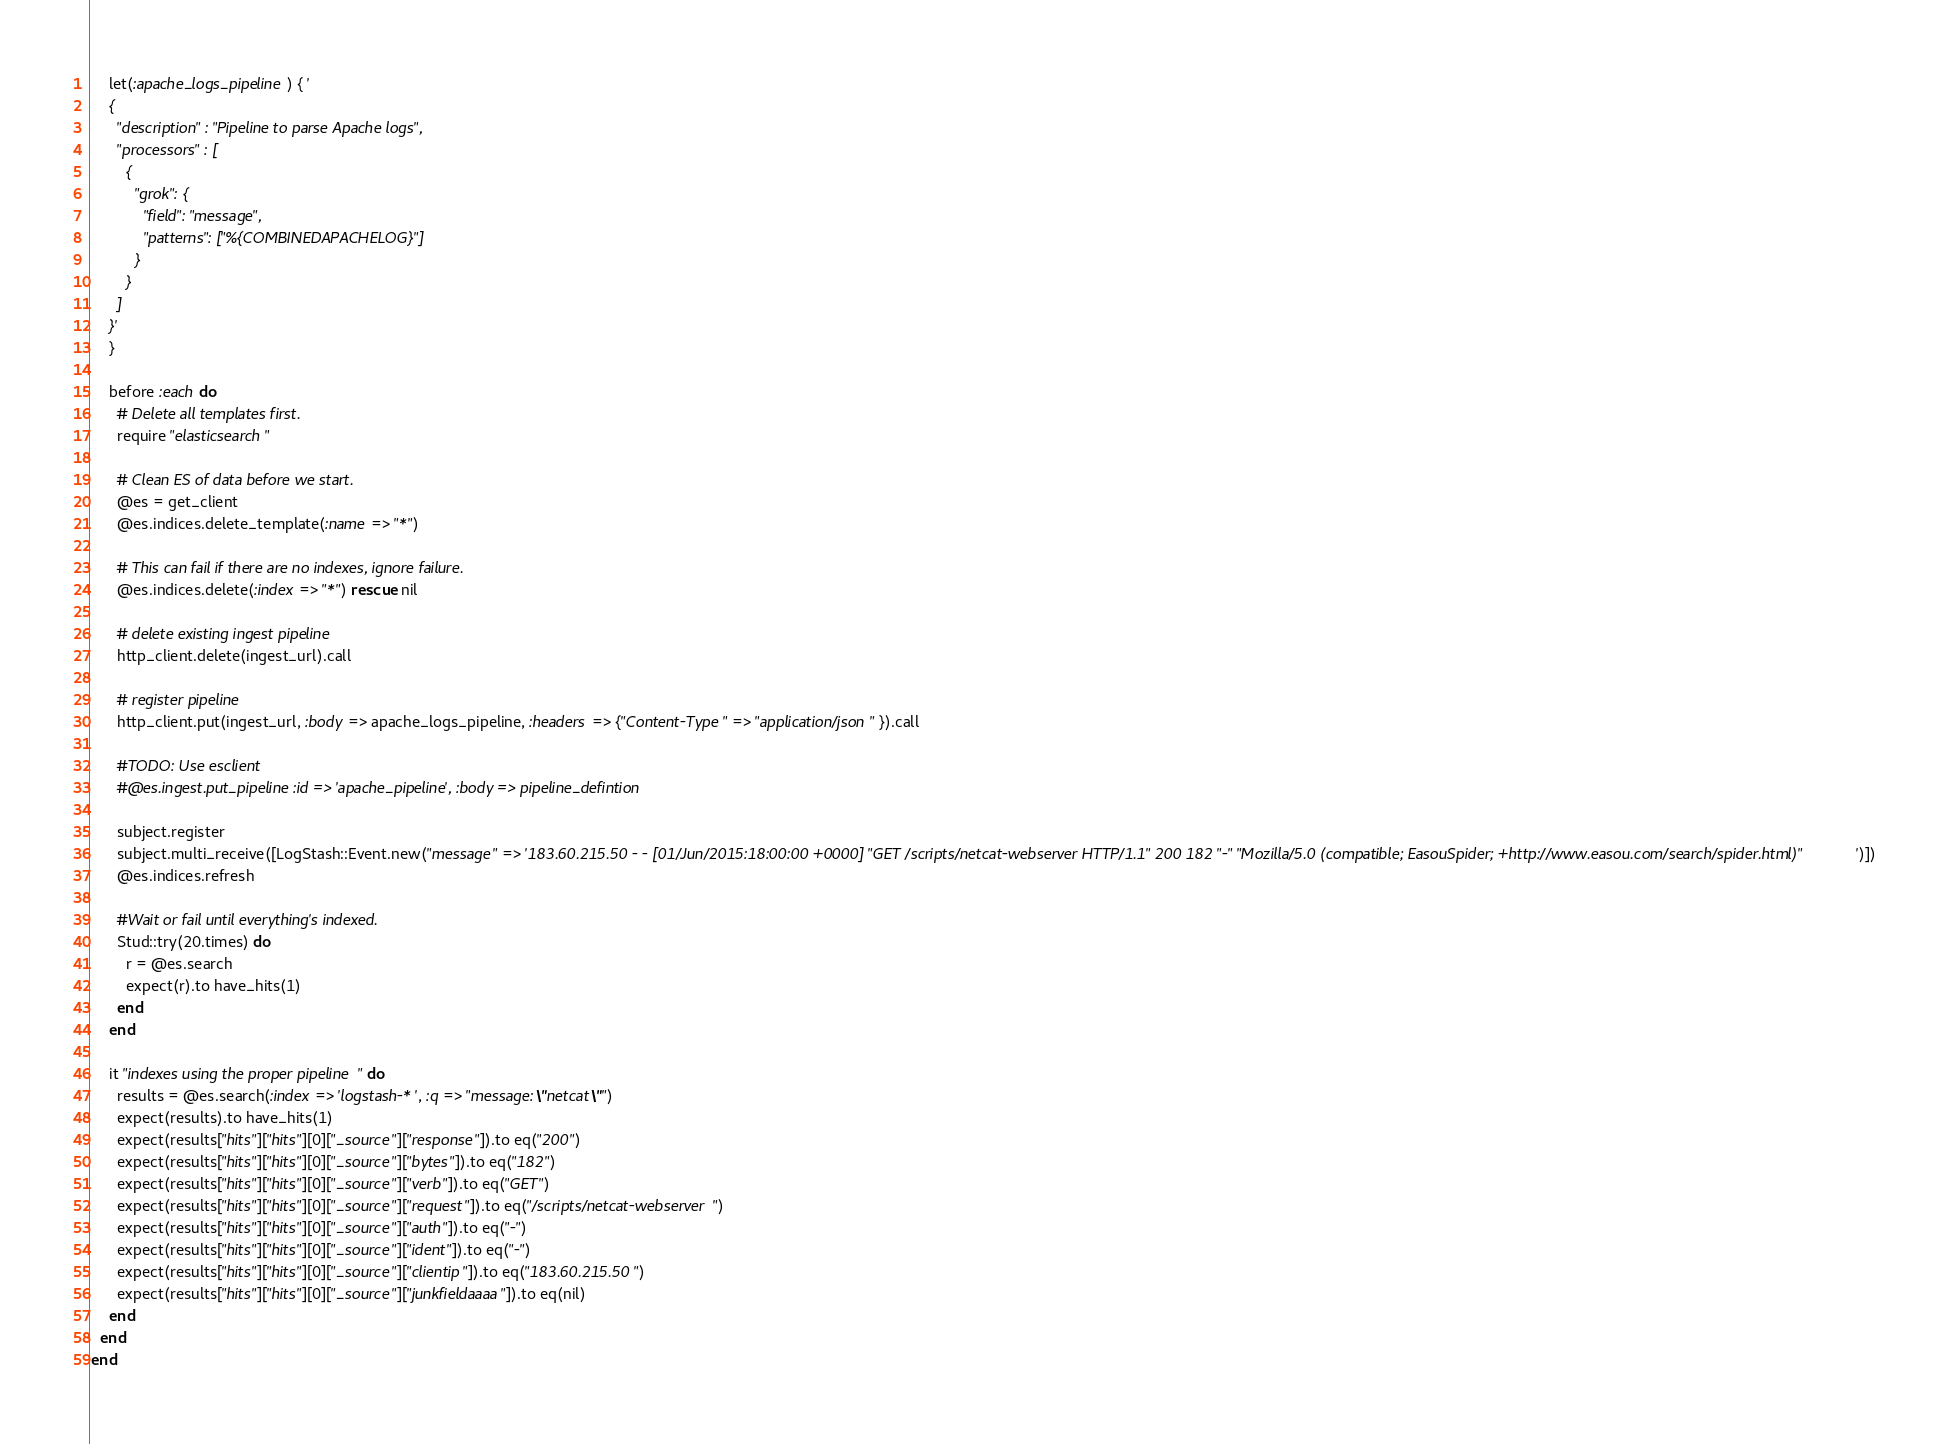<code> <loc_0><loc_0><loc_500><loc_500><_Ruby_>    let(:apache_logs_pipeline) { '
    {
      "description" : "Pipeline to parse Apache logs",
      "processors" : [
        {
          "grok": {
            "field": "message",
            "patterns": ["%{COMBINEDAPACHELOG}"]
          }
        }
      ]
    }'
    }

    before :each do
      # Delete all templates first.
      require "elasticsearch"

      # Clean ES of data before we start.
      @es = get_client
      @es.indices.delete_template(:name => "*")

      # This can fail if there are no indexes, ignore failure.
      @es.indices.delete(:index => "*") rescue nil

      # delete existing ingest pipeline
      http_client.delete(ingest_url).call

      # register pipeline
      http_client.put(ingest_url, :body => apache_logs_pipeline, :headers => {"Content-Type" => "application/json" }).call

      #TODO: Use esclient
      #@es.ingest.put_pipeline :id => 'apache_pipeline', :body => pipeline_defintion

      subject.register
      subject.multi_receive([LogStash::Event.new("message" => '183.60.215.50 - - [01/Jun/2015:18:00:00 +0000] "GET /scripts/netcat-webserver HTTP/1.1" 200 182 "-" "Mozilla/5.0 (compatible; EasouSpider; +http://www.easou.com/search/spider.html)"')])
      @es.indices.refresh

      #Wait or fail until everything's indexed.
      Stud::try(20.times) do
        r = @es.search
        expect(r).to have_hits(1)
      end
    end

    it "indexes using the proper pipeline" do
      results = @es.search(:index => 'logstash-*', :q => "message:\"netcat\"")
      expect(results).to have_hits(1)
      expect(results["hits"]["hits"][0]["_source"]["response"]).to eq("200")
      expect(results["hits"]["hits"][0]["_source"]["bytes"]).to eq("182")
      expect(results["hits"]["hits"][0]["_source"]["verb"]).to eq("GET")
      expect(results["hits"]["hits"][0]["_source"]["request"]).to eq("/scripts/netcat-webserver")
      expect(results["hits"]["hits"][0]["_source"]["auth"]).to eq("-")
      expect(results["hits"]["hits"][0]["_source"]["ident"]).to eq("-")
      expect(results["hits"]["hits"][0]["_source"]["clientip"]).to eq("183.60.215.50")
      expect(results["hits"]["hits"][0]["_source"]["junkfieldaaaa"]).to eq(nil)
    end
  end
end
</code> 